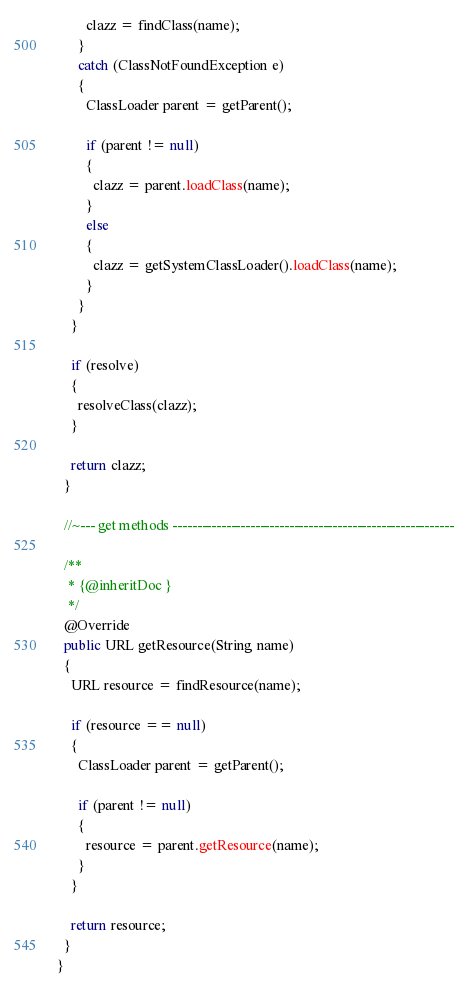<code> <loc_0><loc_0><loc_500><loc_500><_Java_>        clazz = findClass(name);
      }
      catch (ClassNotFoundException e)
      {
        ClassLoader parent = getParent();

        if (parent != null)
        {
          clazz = parent.loadClass(name);
        }
        else
        {
          clazz = getSystemClassLoader().loadClass(name);
        }
      }
    }

    if (resolve)
    {
      resolveClass(clazz);
    }

    return clazz;
  }

  //~--- get methods ----------------------------------------------------------

  /**
   * {@inheritDoc }
   */
  @Override
  public URL getResource(String name)
  {
    URL resource = findResource(name);

    if (resource == null)
    {
      ClassLoader parent = getParent();

      if (parent != null)
      {
        resource = parent.getResource(name);
      }
    }

    return resource;
  }
}
</code> 